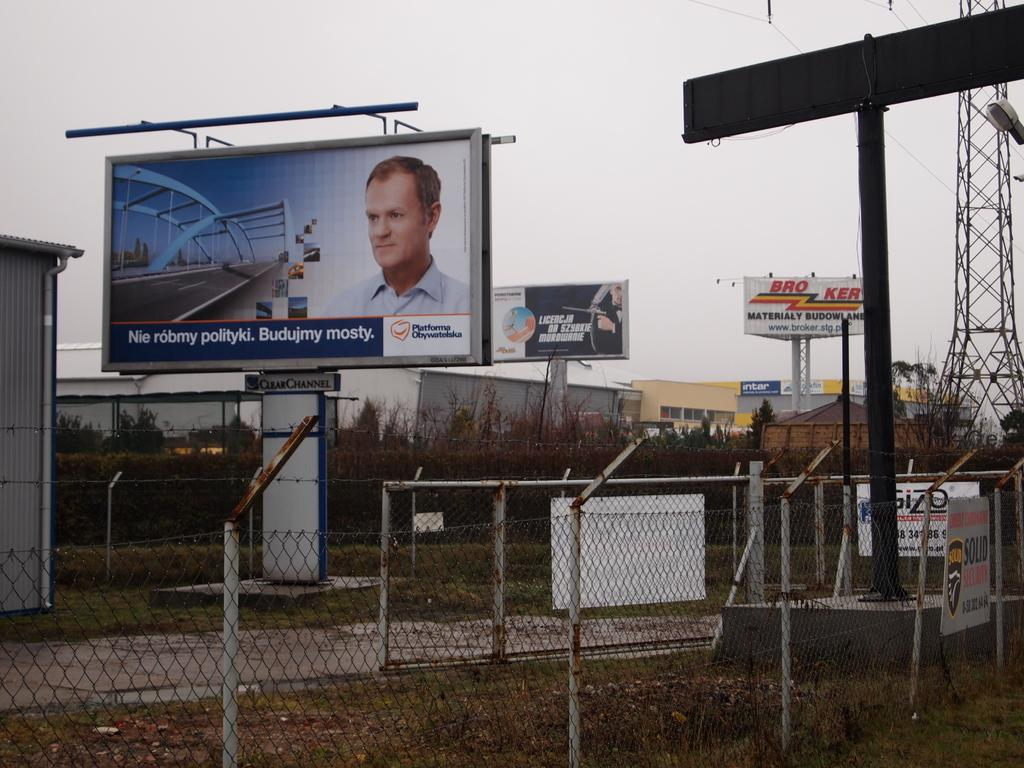<image>
Give a short and clear explanation of the subsequent image. An outdoor billboard with the image of a mans face on it. 